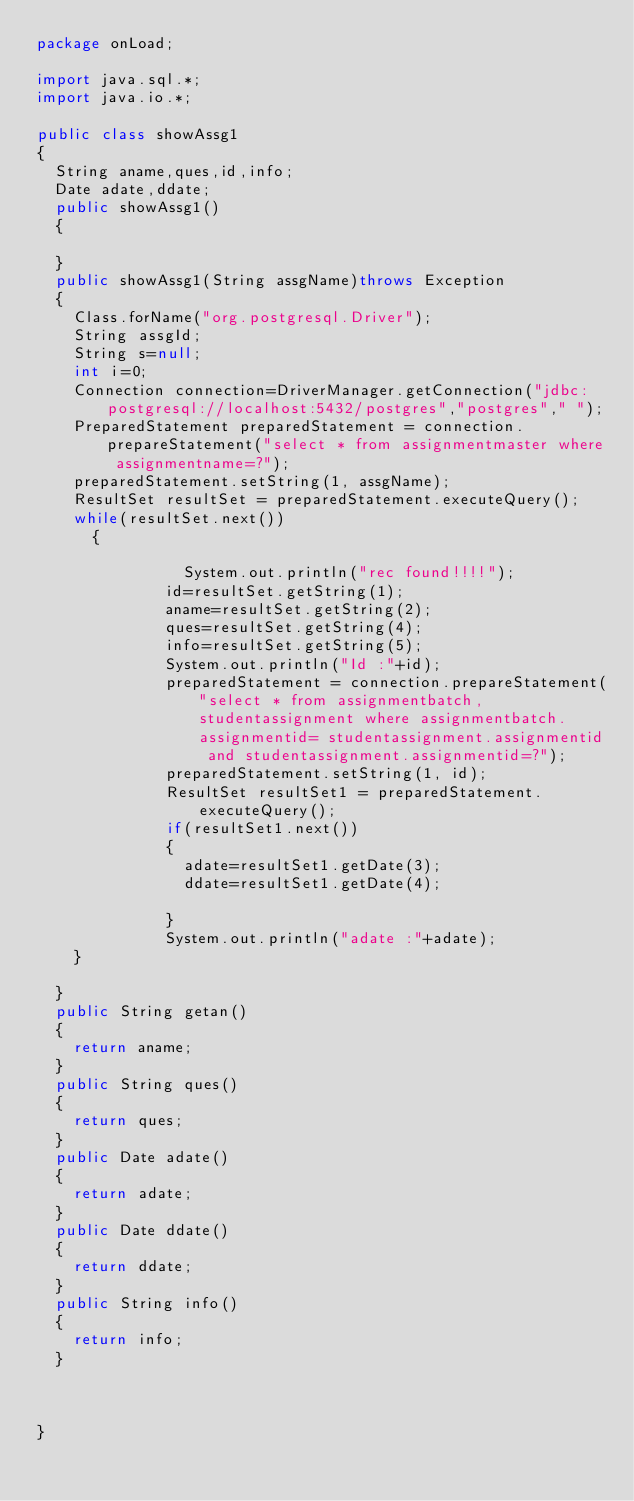Convert code to text. <code><loc_0><loc_0><loc_500><loc_500><_Java_>package onLoad;

import java.sql.*;
import java.io.*;

public class showAssg1
{
	String aname,ques,id,info;
	Date adate,ddate;
	public showAssg1()
	{
	
	}
	public showAssg1(String assgName)throws Exception
	{
		Class.forName("org.postgresql.Driver");
		String assgId;
		String s=null;
		int i=0;
		Connection connection=DriverManager.getConnection("jdbc:postgresql://localhost:5432/postgres","postgres"," ");
		PreparedStatement preparedStatement = connection.prepareStatement("select * from assignmentmaster where assignmentname=?");
		preparedStatement.setString(1, assgName); 
		ResultSet resultSet = preparedStatement.executeQuery();
		while(resultSet.next())
	    {
	    				
	        			System.out.println("rec found!!!!");
    					id=resultSet.getString(1);
    					aname=resultSet.getString(2);
    					ques=resultSet.getString(4);
    					info=resultSet.getString(5);
    					System.out.println("Id :"+id);
    					preparedStatement = connection.prepareStatement("select * from assignmentbatch,studentassignment where assignmentbatch.assignmentid= studentassignment.assignmentid and studentassignment.assignmentid=?");
    					preparedStatement.setString(1, id);
    					ResultSet resultSet1 = preparedStatement.executeQuery();
    					if(resultSet1.next())
    					{
    						adate=resultSet1.getDate(3);
    						ddate=resultSet1.getDate(4);
    						
    					}
    					System.out.println("adate :"+adate);	
		}
		
	}
	public String getan()
	{
		return aname;
	}
	public String ques()
	{
		return ques;
	}
	public Date adate()
	{
		return adate;
	}
	public Date ddate()
	{
		return ddate;
	}
	public String info()
	{
		return info;
	}
	
	
		
}
</code> 